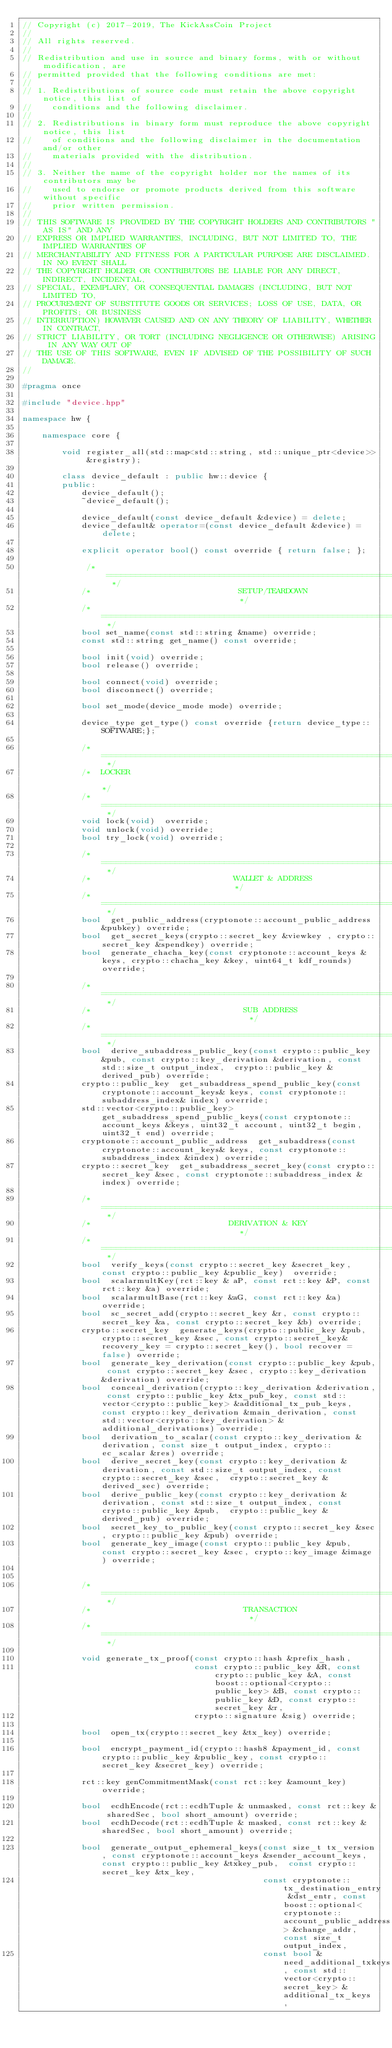<code> <loc_0><loc_0><loc_500><loc_500><_C++_>// Copyright (c) 2017-2019, The KickAssCoin Project
// 
// All rights reserved.
// 
// Redistribution and use in source and binary forms, with or without modification, are
// permitted provided that the following conditions are met:
// 
// 1. Redistributions of source code must retain the above copyright notice, this list of
//    conditions and the following disclaimer.
// 
// 2. Redistributions in binary form must reproduce the above copyright notice, this list
//    of conditions and the following disclaimer in the documentation and/or other
//    materials provided with the distribution.
// 
// 3. Neither the name of the copyright holder nor the names of its contributors may be
//    used to endorse or promote products derived from this software without specific
//    prior written permission.
// 
// THIS SOFTWARE IS PROVIDED BY THE COPYRIGHT HOLDERS AND CONTRIBUTORS "AS IS" AND ANY
// EXPRESS OR IMPLIED WARRANTIES, INCLUDING, BUT NOT LIMITED TO, THE IMPLIED WARRANTIES OF
// MERCHANTABILITY AND FITNESS FOR A PARTICULAR PURPOSE ARE DISCLAIMED. IN NO EVENT SHALL
// THE COPYRIGHT HOLDER OR CONTRIBUTORS BE LIABLE FOR ANY DIRECT, INDIRECT, INCIDENTAL,
// SPECIAL, EXEMPLARY, OR CONSEQUENTIAL DAMAGES (INCLUDING, BUT NOT LIMITED TO,
// PROCUREMENT OF SUBSTITUTE GOODS OR SERVICES; LOSS OF USE, DATA, OR PROFITS; OR BUSINESS
// INTERRUPTION) HOWEVER CAUSED AND ON ANY THEORY OF LIABILITY, WHETHER IN CONTRACT,
// STRICT LIABILITY, OR TORT (INCLUDING NEGLIGENCE OR OTHERWISE) ARISING IN ANY WAY OUT OF
// THE USE OF THIS SOFTWARE, EVEN IF ADVISED OF THE POSSIBILITY OF SUCH DAMAGE.
//

#pragma once

#include "device.hpp"

namespace hw {

    namespace core {

        void register_all(std::map<std::string, std::unique_ptr<device>> &registry);

        class device_default : public hw::device {
        public:
            device_default();
            ~device_default();

            device_default(const device_default &device) = delete;
            device_default& operator=(const device_default &device) = delete;

            explicit operator bool() const override { return false; };

             /* ======================================================================= */
            /*                              SETUP/TEARDOWN                             */
            /* ======================================================================= */
            bool set_name(const std::string &name) override;
            const std::string get_name() const override;

            bool init(void) override;
            bool release() override;

            bool connect(void) override;
            bool disconnect() override;
 
            bool set_mode(device_mode mode) override;

            device_type get_type() const override {return device_type::SOFTWARE;};

            /* ======================================================================= */
            /*  LOCKER                                                                 */
            /* ======================================================================= */ 
            void lock(void)  override;
            void unlock(void) override;
            bool try_lock(void) override;
            
            /* ======================================================================= */
            /*                             WALLET & ADDRESS                            */
            /* ======================================================================= */
            bool  get_public_address(cryptonote::account_public_address &pubkey) override;
            bool  get_secret_keys(crypto::secret_key &viewkey , crypto::secret_key &spendkey) override;
            bool  generate_chacha_key(const cryptonote::account_keys &keys, crypto::chacha_key &key, uint64_t kdf_rounds) override;
 
            /* ======================================================================= */
            /*                               SUB ADDRESS                               */
            /* ======================================================================= */
            bool  derive_subaddress_public_key(const crypto::public_key &pub, const crypto::key_derivation &derivation, const std::size_t output_index,  crypto::public_key &derived_pub) override;
            crypto::public_key  get_subaddress_spend_public_key(const cryptonote::account_keys& keys, const cryptonote::subaddress_index& index) override;
            std::vector<crypto::public_key>  get_subaddress_spend_public_keys(const cryptonote::account_keys &keys, uint32_t account, uint32_t begin, uint32_t end) override;
            cryptonote::account_public_address  get_subaddress(const cryptonote::account_keys& keys, const cryptonote::subaddress_index &index) override;
            crypto::secret_key  get_subaddress_secret_key(const crypto::secret_key &sec, const cryptonote::subaddress_index &index) override;

            /* ======================================================================= */
            /*                            DERIVATION & KEY                             */
            /* ======================================================================= */
            bool  verify_keys(const crypto::secret_key &secret_key, const crypto::public_key &public_key)  override;
            bool  scalarmultKey(rct::key & aP, const rct::key &P, const rct::key &a) override;
            bool  scalarmultBase(rct::key &aG, const rct::key &a) override;
            bool  sc_secret_add(crypto::secret_key &r, const crypto::secret_key &a, const crypto::secret_key &b) override;
            crypto::secret_key  generate_keys(crypto::public_key &pub, crypto::secret_key &sec, const crypto::secret_key& recovery_key = crypto::secret_key(), bool recover = false) override;
            bool  generate_key_derivation(const crypto::public_key &pub, const crypto::secret_key &sec, crypto::key_derivation &derivation) override;
            bool  conceal_derivation(crypto::key_derivation &derivation, const crypto::public_key &tx_pub_key, const std::vector<crypto::public_key> &additional_tx_pub_keys, const crypto::key_derivation &main_derivation, const std::vector<crypto::key_derivation> &additional_derivations) override;
            bool  derivation_to_scalar(const crypto::key_derivation &derivation, const size_t output_index, crypto::ec_scalar &res) override;
            bool  derive_secret_key(const crypto::key_derivation &derivation, const std::size_t output_index, const crypto::secret_key &sec,  crypto::secret_key &derived_sec) override;
            bool  derive_public_key(const crypto::key_derivation &derivation, const std::size_t output_index, const crypto::public_key &pub,  crypto::public_key &derived_pub) override;
            bool  secret_key_to_public_key(const crypto::secret_key &sec, crypto::public_key &pub) override;
            bool  generate_key_image(const crypto::public_key &pub, const crypto::secret_key &sec, crypto::key_image &image) override;


            /* ======================================================================= */
            /*                               TRANSACTION                               */
            /* ======================================================================= */

            void generate_tx_proof(const crypto::hash &prefix_hash, 
                                   const crypto::public_key &R, const crypto::public_key &A, const boost::optional<crypto::public_key> &B, const crypto::public_key &D, const crypto::secret_key &r, 
                                   crypto::signature &sig) override;

            bool  open_tx(crypto::secret_key &tx_key) override;

            bool  encrypt_payment_id(crypto::hash8 &payment_id, const crypto::public_key &public_key, const crypto::secret_key &secret_key) override;

            rct::key genCommitmentMask(const rct::key &amount_key) override;

            bool  ecdhEncode(rct::ecdhTuple & unmasked, const rct::key & sharedSec, bool short_amount) override;
            bool  ecdhDecode(rct::ecdhTuple & masked, const rct::key & sharedSec, bool short_amount) override;

            bool  generate_output_ephemeral_keys(const size_t tx_version, const cryptonote::account_keys &sender_account_keys, const crypto::public_key &txkey_pub,  const crypto::secret_key &tx_key,
                                                 const cryptonote::tx_destination_entry &dst_entr, const boost::optional<cryptonote::account_public_address> &change_addr, const size_t output_index,
                                                 const bool &need_additional_txkeys, const std::vector<crypto::secret_key> &additional_tx_keys,</code> 